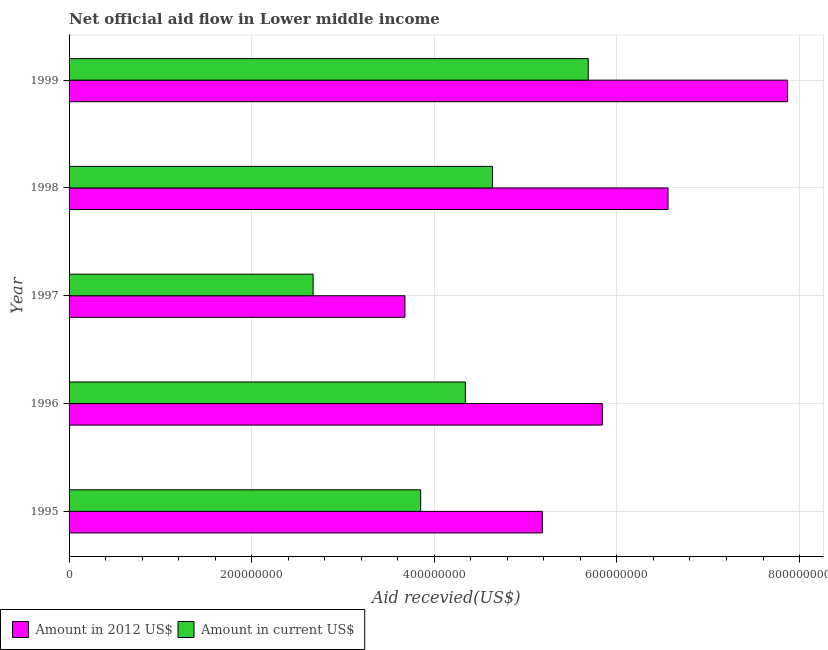How many different coloured bars are there?
Make the answer very short. 2. What is the amount of aid received(expressed in us$) in 1998?
Give a very brief answer. 4.64e+08. Across all years, what is the maximum amount of aid received(expressed in 2012 us$)?
Give a very brief answer. 7.87e+08. Across all years, what is the minimum amount of aid received(expressed in us$)?
Your response must be concise. 2.67e+08. In which year was the amount of aid received(expressed in us$) minimum?
Provide a short and direct response. 1997. What is the total amount of aid received(expressed in 2012 us$) in the graph?
Provide a short and direct response. 2.91e+09. What is the difference between the amount of aid received(expressed in us$) in 1996 and that in 1997?
Offer a terse response. 1.67e+08. What is the difference between the amount of aid received(expressed in us$) in 1998 and the amount of aid received(expressed in 2012 us$) in 1997?
Offer a terse response. 9.59e+07. What is the average amount of aid received(expressed in 2012 us$) per year?
Your response must be concise. 5.83e+08. In the year 1995, what is the difference between the amount of aid received(expressed in us$) and amount of aid received(expressed in 2012 us$)?
Offer a terse response. -1.33e+08. In how many years, is the amount of aid received(expressed in us$) greater than 760000000 US$?
Offer a very short reply. 0. What is the ratio of the amount of aid received(expressed in 2012 us$) in 1997 to that in 1999?
Offer a terse response. 0.47. What is the difference between the highest and the second highest amount of aid received(expressed in us$)?
Make the answer very short. 1.05e+08. What is the difference between the highest and the lowest amount of aid received(expressed in us$)?
Your answer should be very brief. 3.01e+08. Is the sum of the amount of aid received(expressed in us$) in 1995 and 1997 greater than the maximum amount of aid received(expressed in 2012 us$) across all years?
Provide a succinct answer. No. What does the 2nd bar from the top in 1999 represents?
Your response must be concise. Amount in 2012 US$. What does the 2nd bar from the bottom in 1999 represents?
Your response must be concise. Amount in current US$. How many bars are there?
Keep it short and to the point. 10. Are all the bars in the graph horizontal?
Make the answer very short. Yes. How many years are there in the graph?
Your answer should be compact. 5. What is the difference between two consecutive major ticks on the X-axis?
Make the answer very short. 2.00e+08. Does the graph contain any zero values?
Make the answer very short. No. How many legend labels are there?
Provide a short and direct response. 2. How are the legend labels stacked?
Offer a terse response. Horizontal. What is the title of the graph?
Your answer should be compact. Net official aid flow in Lower middle income. What is the label or title of the X-axis?
Your response must be concise. Aid recevied(US$). What is the label or title of the Y-axis?
Keep it short and to the point. Year. What is the Aid recevied(US$) of Amount in 2012 US$ in 1995?
Give a very brief answer. 5.18e+08. What is the Aid recevied(US$) in Amount in current US$ in 1995?
Give a very brief answer. 3.85e+08. What is the Aid recevied(US$) in Amount in 2012 US$ in 1996?
Keep it short and to the point. 5.84e+08. What is the Aid recevied(US$) of Amount in current US$ in 1996?
Make the answer very short. 4.34e+08. What is the Aid recevied(US$) in Amount in 2012 US$ in 1997?
Your answer should be very brief. 3.68e+08. What is the Aid recevied(US$) in Amount in current US$ in 1997?
Provide a short and direct response. 2.67e+08. What is the Aid recevied(US$) in Amount in 2012 US$ in 1998?
Ensure brevity in your answer.  6.56e+08. What is the Aid recevied(US$) of Amount in current US$ in 1998?
Offer a very short reply. 4.64e+08. What is the Aid recevied(US$) of Amount in 2012 US$ in 1999?
Your answer should be very brief. 7.87e+08. What is the Aid recevied(US$) of Amount in current US$ in 1999?
Make the answer very short. 5.69e+08. Across all years, what is the maximum Aid recevied(US$) of Amount in 2012 US$?
Your answer should be very brief. 7.87e+08. Across all years, what is the maximum Aid recevied(US$) in Amount in current US$?
Provide a succinct answer. 5.69e+08. Across all years, what is the minimum Aid recevied(US$) in Amount in 2012 US$?
Offer a terse response. 3.68e+08. Across all years, what is the minimum Aid recevied(US$) in Amount in current US$?
Give a very brief answer. 2.67e+08. What is the total Aid recevied(US$) in Amount in 2012 US$ in the graph?
Make the answer very short. 2.91e+09. What is the total Aid recevied(US$) of Amount in current US$ in the graph?
Your response must be concise. 2.12e+09. What is the difference between the Aid recevied(US$) in Amount in 2012 US$ in 1995 and that in 1996?
Offer a very short reply. -6.56e+07. What is the difference between the Aid recevied(US$) in Amount in current US$ in 1995 and that in 1996?
Your answer should be very brief. -4.89e+07. What is the difference between the Aid recevied(US$) of Amount in 2012 US$ in 1995 and that in 1997?
Your answer should be very brief. 1.50e+08. What is the difference between the Aid recevied(US$) in Amount in current US$ in 1995 and that in 1997?
Your answer should be very brief. 1.18e+08. What is the difference between the Aid recevied(US$) in Amount in 2012 US$ in 1995 and that in 1998?
Your answer should be very brief. -1.38e+08. What is the difference between the Aid recevied(US$) of Amount in current US$ in 1995 and that in 1998?
Keep it short and to the point. -7.87e+07. What is the difference between the Aid recevied(US$) in Amount in 2012 US$ in 1995 and that in 1999?
Offer a very short reply. -2.69e+08. What is the difference between the Aid recevied(US$) in Amount in current US$ in 1995 and that in 1999?
Offer a very short reply. -1.84e+08. What is the difference between the Aid recevied(US$) in Amount in 2012 US$ in 1996 and that in 1997?
Make the answer very short. 2.16e+08. What is the difference between the Aid recevied(US$) in Amount in current US$ in 1996 and that in 1997?
Offer a terse response. 1.67e+08. What is the difference between the Aid recevied(US$) of Amount in 2012 US$ in 1996 and that in 1998?
Your response must be concise. -7.20e+07. What is the difference between the Aid recevied(US$) in Amount in current US$ in 1996 and that in 1998?
Keep it short and to the point. -2.98e+07. What is the difference between the Aid recevied(US$) of Amount in 2012 US$ in 1996 and that in 1999?
Give a very brief answer. -2.03e+08. What is the difference between the Aid recevied(US$) of Amount in current US$ in 1996 and that in 1999?
Your answer should be very brief. -1.35e+08. What is the difference between the Aid recevied(US$) in Amount in 2012 US$ in 1997 and that in 1998?
Ensure brevity in your answer.  -2.88e+08. What is the difference between the Aid recevied(US$) of Amount in current US$ in 1997 and that in 1998?
Your answer should be compact. -1.96e+08. What is the difference between the Aid recevied(US$) in Amount in 2012 US$ in 1997 and that in 1999?
Keep it short and to the point. -4.19e+08. What is the difference between the Aid recevied(US$) in Amount in current US$ in 1997 and that in 1999?
Make the answer very short. -3.01e+08. What is the difference between the Aid recevied(US$) of Amount in 2012 US$ in 1998 and that in 1999?
Make the answer very short. -1.31e+08. What is the difference between the Aid recevied(US$) in Amount in current US$ in 1998 and that in 1999?
Give a very brief answer. -1.05e+08. What is the difference between the Aid recevied(US$) in Amount in 2012 US$ in 1995 and the Aid recevied(US$) in Amount in current US$ in 1996?
Provide a short and direct response. 8.43e+07. What is the difference between the Aid recevied(US$) in Amount in 2012 US$ in 1995 and the Aid recevied(US$) in Amount in current US$ in 1997?
Make the answer very short. 2.51e+08. What is the difference between the Aid recevied(US$) of Amount in 2012 US$ in 1995 and the Aid recevied(US$) of Amount in current US$ in 1998?
Your answer should be very brief. 5.46e+07. What is the difference between the Aid recevied(US$) in Amount in 2012 US$ in 1995 and the Aid recevied(US$) in Amount in current US$ in 1999?
Make the answer very short. -5.02e+07. What is the difference between the Aid recevied(US$) of Amount in 2012 US$ in 1996 and the Aid recevied(US$) of Amount in current US$ in 1997?
Your response must be concise. 3.17e+08. What is the difference between the Aid recevied(US$) of Amount in 2012 US$ in 1996 and the Aid recevied(US$) of Amount in current US$ in 1998?
Offer a terse response. 1.20e+08. What is the difference between the Aid recevied(US$) in Amount in 2012 US$ in 1996 and the Aid recevied(US$) in Amount in current US$ in 1999?
Your answer should be very brief. 1.54e+07. What is the difference between the Aid recevied(US$) of Amount in 2012 US$ in 1997 and the Aid recevied(US$) of Amount in current US$ in 1998?
Your answer should be very brief. -9.59e+07. What is the difference between the Aid recevied(US$) in Amount in 2012 US$ in 1997 and the Aid recevied(US$) in Amount in current US$ in 1999?
Give a very brief answer. -2.01e+08. What is the difference between the Aid recevied(US$) of Amount in 2012 US$ in 1998 and the Aid recevied(US$) of Amount in current US$ in 1999?
Give a very brief answer. 8.74e+07. What is the average Aid recevied(US$) of Amount in 2012 US$ per year?
Ensure brevity in your answer.  5.83e+08. What is the average Aid recevied(US$) of Amount in current US$ per year?
Offer a terse response. 4.24e+08. In the year 1995, what is the difference between the Aid recevied(US$) in Amount in 2012 US$ and Aid recevied(US$) in Amount in current US$?
Offer a very short reply. 1.33e+08. In the year 1996, what is the difference between the Aid recevied(US$) in Amount in 2012 US$ and Aid recevied(US$) in Amount in current US$?
Provide a short and direct response. 1.50e+08. In the year 1997, what is the difference between the Aid recevied(US$) of Amount in 2012 US$ and Aid recevied(US$) of Amount in current US$?
Make the answer very short. 1.01e+08. In the year 1998, what is the difference between the Aid recevied(US$) of Amount in 2012 US$ and Aid recevied(US$) of Amount in current US$?
Your answer should be compact. 1.92e+08. In the year 1999, what is the difference between the Aid recevied(US$) in Amount in 2012 US$ and Aid recevied(US$) in Amount in current US$?
Provide a succinct answer. 2.18e+08. What is the ratio of the Aid recevied(US$) in Amount in 2012 US$ in 1995 to that in 1996?
Provide a succinct answer. 0.89. What is the ratio of the Aid recevied(US$) in Amount in current US$ in 1995 to that in 1996?
Your response must be concise. 0.89. What is the ratio of the Aid recevied(US$) of Amount in 2012 US$ in 1995 to that in 1997?
Give a very brief answer. 1.41. What is the ratio of the Aid recevied(US$) in Amount in current US$ in 1995 to that in 1997?
Keep it short and to the point. 1.44. What is the ratio of the Aid recevied(US$) in Amount in 2012 US$ in 1995 to that in 1998?
Keep it short and to the point. 0.79. What is the ratio of the Aid recevied(US$) in Amount in current US$ in 1995 to that in 1998?
Give a very brief answer. 0.83. What is the ratio of the Aid recevied(US$) in Amount in 2012 US$ in 1995 to that in 1999?
Make the answer very short. 0.66. What is the ratio of the Aid recevied(US$) of Amount in current US$ in 1995 to that in 1999?
Offer a very short reply. 0.68. What is the ratio of the Aid recevied(US$) of Amount in 2012 US$ in 1996 to that in 1997?
Your response must be concise. 1.59. What is the ratio of the Aid recevied(US$) of Amount in current US$ in 1996 to that in 1997?
Ensure brevity in your answer.  1.62. What is the ratio of the Aid recevied(US$) of Amount in 2012 US$ in 1996 to that in 1998?
Your answer should be compact. 0.89. What is the ratio of the Aid recevied(US$) in Amount in current US$ in 1996 to that in 1998?
Your answer should be very brief. 0.94. What is the ratio of the Aid recevied(US$) in Amount in 2012 US$ in 1996 to that in 1999?
Offer a terse response. 0.74. What is the ratio of the Aid recevied(US$) in Amount in current US$ in 1996 to that in 1999?
Offer a terse response. 0.76. What is the ratio of the Aid recevied(US$) of Amount in 2012 US$ in 1997 to that in 1998?
Offer a terse response. 0.56. What is the ratio of the Aid recevied(US$) in Amount in current US$ in 1997 to that in 1998?
Offer a terse response. 0.58. What is the ratio of the Aid recevied(US$) of Amount in 2012 US$ in 1997 to that in 1999?
Make the answer very short. 0.47. What is the ratio of the Aid recevied(US$) in Amount in current US$ in 1997 to that in 1999?
Ensure brevity in your answer.  0.47. What is the ratio of the Aid recevied(US$) of Amount in 2012 US$ in 1998 to that in 1999?
Offer a terse response. 0.83. What is the ratio of the Aid recevied(US$) in Amount in current US$ in 1998 to that in 1999?
Ensure brevity in your answer.  0.82. What is the difference between the highest and the second highest Aid recevied(US$) of Amount in 2012 US$?
Your answer should be compact. 1.31e+08. What is the difference between the highest and the second highest Aid recevied(US$) in Amount in current US$?
Make the answer very short. 1.05e+08. What is the difference between the highest and the lowest Aid recevied(US$) in Amount in 2012 US$?
Give a very brief answer. 4.19e+08. What is the difference between the highest and the lowest Aid recevied(US$) of Amount in current US$?
Provide a succinct answer. 3.01e+08. 